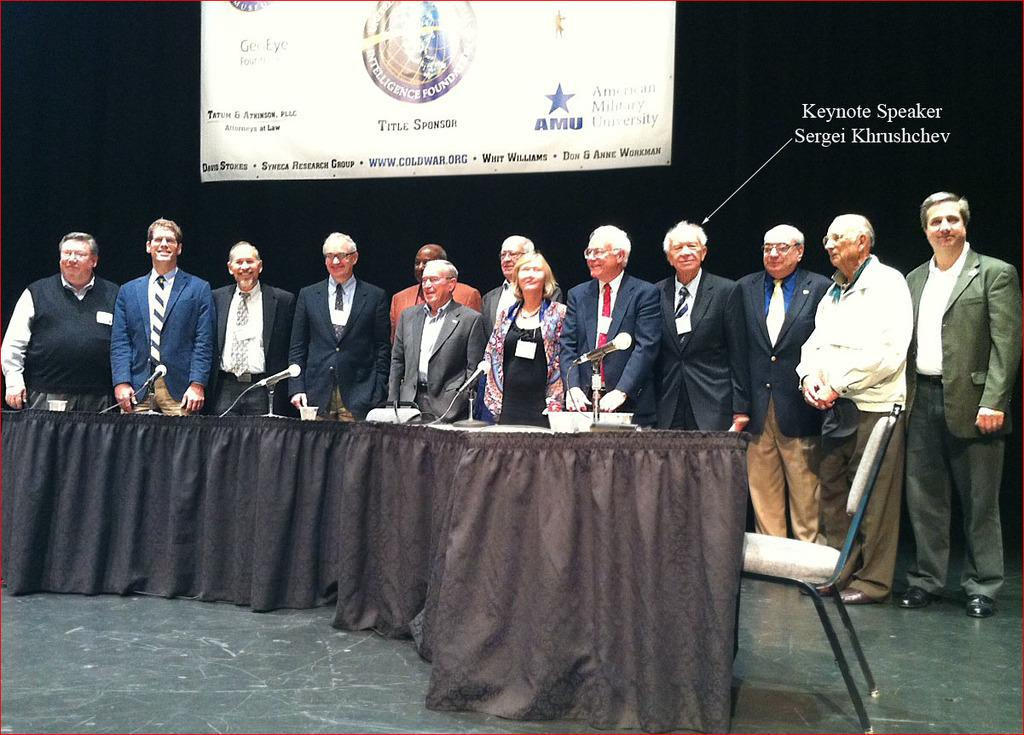What are the people in the image doing? The people in the image are on the floor. What piece of furniture is present in the image? There is a chair in the image. What devices are visible in the image? There are microphones (mics) in the image. Can you describe the background of the image? There is a banner and text visible in the background of the image. What type of smoke can be seen coming from the microphones in the image? There is no smoke visible in the image, and the microphones are not producing any smoke. 